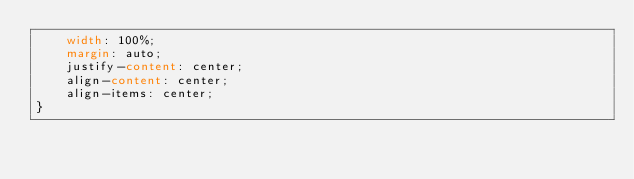<code> <loc_0><loc_0><loc_500><loc_500><_CSS_>    width: 100%;
    margin: auto;
    justify-content: center;
    align-content: center;
    align-items: center;
}</code> 